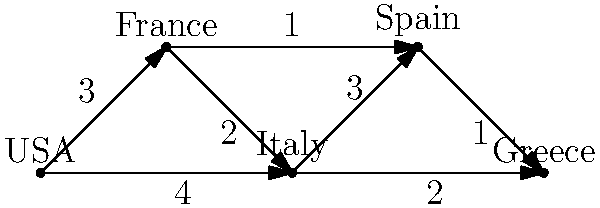In the graph representing the information flow between republican movements in different countries, what is the shortest path for information to travel from the USA to Greece, and what is its total weight? To find the shortest path from USA to Greece, we'll use Dijkstra's algorithm:

1. Initialize:
   - USA: 0
   - All other nodes: infinity

2. From USA:
   - To France: 3
   - To Italy: 4
   Update: USA(0), France(3), Italy(4), Spain(∞), Greece(∞)

3. From France:
   - To Italy: 3 + 2 = 5 (don't update, 4 is better)
   - To Spain: 3 + 1 = 4
   Update: USA(0), France(3), Italy(4), Spain(4), Greece(∞)

4. From Italy:
   - To Spain: 4 + 3 = 7 (don't update, 4 is better)
   - To Greece: 4 + 2 = 6
   Update: USA(0), France(3), Italy(4), Spain(4), Greece(6)

5. From Spain:
   - To Greece: 4 + 1 = 5
   Update: USA(0), France(3), Italy(4), Spain(4), Greece(5)

The shortest path is USA -> France -> Spain -> Greece, with a total weight of 5.
Answer: USA -> France -> Spain -> Greece; total weight: 5 